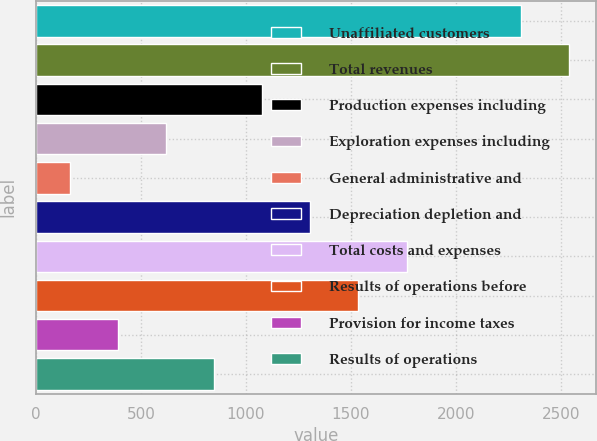Convert chart. <chart><loc_0><loc_0><loc_500><loc_500><bar_chart><fcel>Unaffiliated customers<fcel>Total revenues<fcel>Production expenses including<fcel>Exploration expenses including<fcel>General administrative and<fcel>Depreciation depletion and<fcel>Total costs and expenses<fcel>Results of operations before<fcel>Provision for income taxes<fcel>Results of operations<nl><fcel>2310<fcel>2539.2<fcel>1077.8<fcel>619.4<fcel>161<fcel>1307<fcel>1765.4<fcel>1536.2<fcel>390.2<fcel>848.6<nl></chart> 